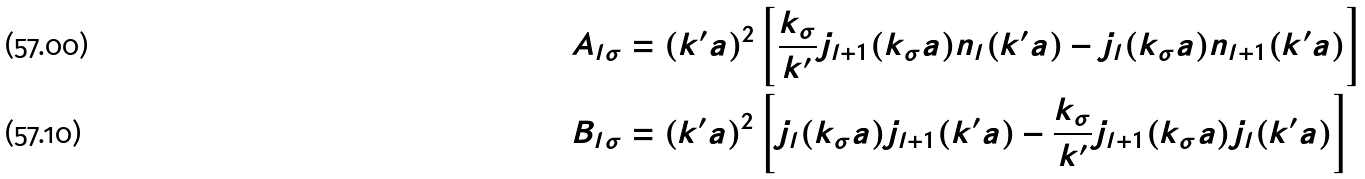<formula> <loc_0><loc_0><loc_500><loc_500>& A _ { l \sigma } = ( k ^ { \prime } a ) ^ { 2 } \left [ \frac { k _ { \sigma } } { k ^ { \prime } } j _ { l + 1 } ( k _ { \sigma } a ) n _ { l } ( k ^ { \prime } a ) - j _ { l } ( k _ { \sigma } a ) n _ { l + 1 } ( k ^ { \prime } a ) \right ] \\ & B _ { l \sigma } = ( k ^ { \prime } a ) ^ { 2 } \left [ j _ { l } ( k _ { \sigma } a ) j _ { l + 1 } ( k ^ { \prime } a ) - \frac { k _ { \sigma } } { k ^ { \prime } } j _ { l + 1 } ( k _ { \sigma } a ) j _ { l } ( k ^ { \prime } a ) \right ]</formula> 